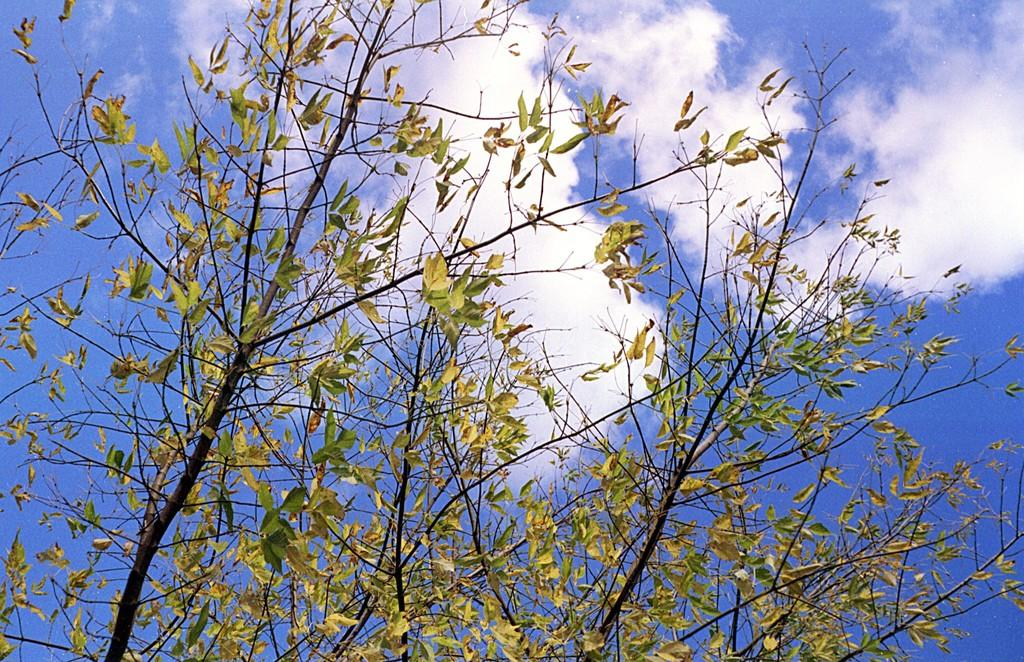What type of plant can be seen in the image? There is a tree in the image. What can be seen in the sky in the image? There are clouds in the sky in the image. What type of knowledge is being shared in the image? There is no indication of knowledge being shared in the image; it features a tree and clouds in the sky. How are the clouds in the image being sorted? There is no sorting of clouds in the image; they are simply visible in the sky. 